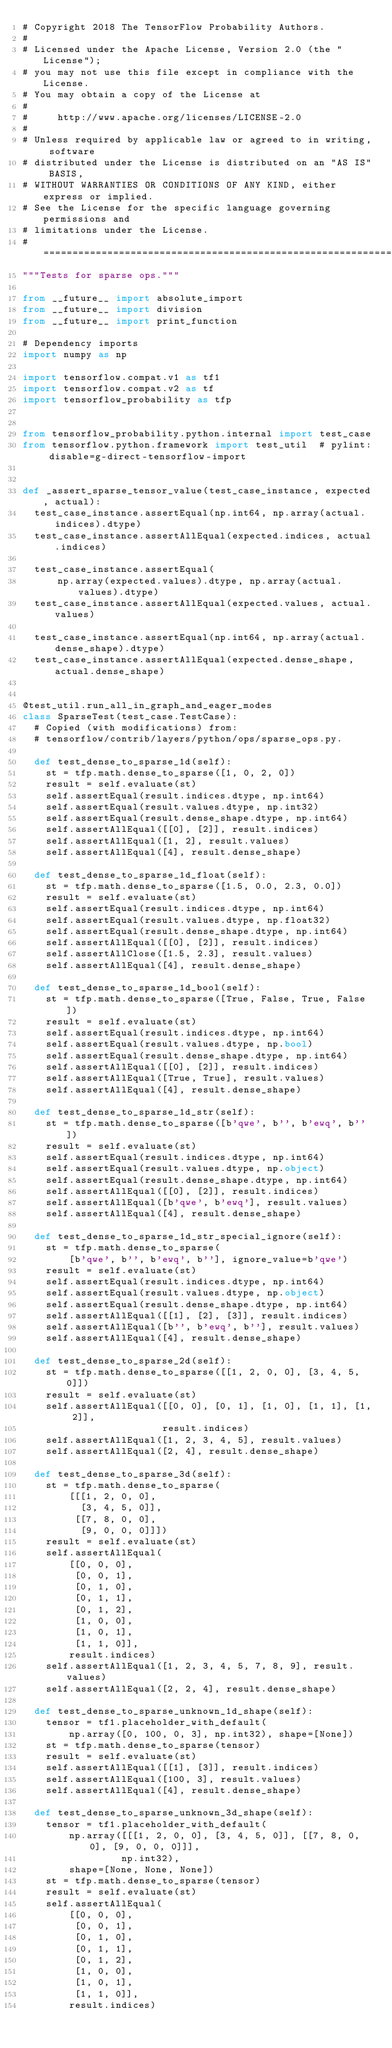<code> <loc_0><loc_0><loc_500><loc_500><_Python_># Copyright 2018 The TensorFlow Probability Authors.
#
# Licensed under the Apache License, Version 2.0 (the "License");
# you may not use this file except in compliance with the License.
# You may obtain a copy of the License at
#
#     http://www.apache.org/licenses/LICENSE-2.0
#
# Unless required by applicable law or agreed to in writing, software
# distributed under the License is distributed on an "AS IS" BASIS,
# WITHOUT WARRANTIES OR CONDITIONS OF ANY KIND, either express or implied.
# See the License for the specific language governing permissions and
# limitations under the License.
# ============================================================================
"""Tests for sparse ops."""

from __future__ import absolute_import
from __future__ import division
from __future__ import print_function

# Dependency imports
import numpy as np

import tensorflow.compat.v1 as tf1
import tensorflow.compat.v2 as tf
import tensorflow_probability as tfp


from tensorflow_probability.python.internal import test_case
from tensorflow.python.framework import test_util  # pylint: disable=g-direct-tensorflow-import


def _assert_sparse_tensor_value(test_case_instance, expected, actual):
  test_case_instance.assertEqual(np.int64, np.array(actual.indices).dtype)
  test_case_instance.assertAllEqual(expected.indices, actual.indices)

  test_case_instance.assertEqual(
      np.array(expected.values).dtype, np.array(actual.values).dtype)
  test_case_instance.assertAllEqual(expected.values, actual.values)

  test_case_instance.assertEqual(np.int64, np.array(actual.dense_shape).dtype)
  test_case_instance.assertAllEqual(expected.dense_shape, actual.dense_shape)


@test_util.run_all_in_graph_and_eager_modes
class SparseTest(test_case.TestCase):
  # Copied (with modifications) from:
  # tensorflow/contrib/layers/python/ops/sparse_ops.py.

  def test_dense_to_sparse_1d(self):
    st = tfp.math.dense_to_sparse([1, 0, 2, 0])
    result = self.evaluate(st)
    self.assertEqual(result.indices.dtype, np.int64)
    self.assertEqual(result.values.dtype, np.int32)
    self.assertEqual(result.dense_shape.dtype, np.int64)
    self.assertAllEqual([[0], [2]], result.indices)
    self.assertAllEqual([1, 2], result.values)
    self.assertAllEqual([4], result.dense_shape)

  def test_dense_to_sparse_1d_float(self):
    st = tfp.math.dense_to_sparse([1.5, 0.0, 2.3, 0.0])
    result = self.evaluate(st)
    self.assertEqual(result.indices.dtype, np.int64)
    self.assertEqual(result.values.dtype, np.float32)
    self.assertEqual(result.dense_shape.dtype, np.int64)
    self.assertAllEqual([[0], [2]], result.indices)
    self.assertAllClose([1.5, 2.3], result.values)
    self.assertAllEqual([4], result.dense_shape)

  def test_dense_to_sparse_1d_bool(self):
    st = tfp.math.dense_to_sparse([True, False, True, False])
    result = self.evaluate(st)
    self.assertEqual(result.indices.dtype, np.int64)
    self.assertEqual(result.values.dtype, np.bool)
    self.assertEqual(result.dense_shape.dtype, np.int64)
    self.assertAllEqual([[0], [2]], result.indices)
    self.assertAllEqual([True, True], result.values)
    self.assertAllEqual([4], result.dense_shape)

  def test_dense_to_sparse_1d_str(self):
    st = tfp.math.dense_to_sparse([b'qwe', b'', b'ewq', b''])
    result = self.evaluate(st)
    self.assertEqual(result.indices.dtype, np.int64)
    self.assertEqual(result.values.dtype, np.object)
    self.assertEqual(result.dense_shape.dtype, np.int64)
    self.assertAllEqual([[0], [2]], result.indices)
    self.assertAllEqual([b'qwe', b'ewq'], result.values)
    self.assertAllEqual([4], result.dense_shape)

  def test_dense_to_sparse_1d_str_special_ignore(self):
    st = tfp.math.dense_to_sparse(
        [b'qwe', b'', b'ewq', b''], ignore_value=b'qwe')
    result = self.evaluate(st)
    self.assertEqual(result.indices.dtype, np.int64)
    self.assertEqual(result.values.dtype, np.object)
    self.assertEqual(result.dense_shape.dtype, np.int64)
    self.assertAllEqual([[1], [2], [3]], result.indices)
    self.assertAllEqual([b'', b'ewq', b''], result.values)
    self.assertAllEqual([4], result.dense_shape)

  def test_dense_to_sparse_2d(self):
    st = tfp.math.dense_to_sparse([[1, 2, 0, 0], [3, 4, 5, 0]])
    result = self.evaluate(st)
    self.assertAllEqual([[0, 0], [0, 1], [1, 0], [1, 1], [1, 2]],
                        result.indices)
    self.assertAllEqual([1, 2, 3, 4, 5], result.values)
    self.assertAllEqual([2, 4], result.dense_shape)

  def test_dense_to_sparse_3d(self):
    st = tfp.math.dense_to_sparse(
        [[[1, 2, 0, 0],
          [3, 4, 5, 0]],
         [[7, 8, 0, 0],
          [9, 0, 0, 0]]])
    result = self.evaluate(st)
    self.assertAllEqual(
        [[0, 0, 0],
         [0, 0, 1],
         [0, 1, 0],
         [0, 1, 1],
         [0, 1, 2],
         [1, 0, 0],
         [1, 0, 1],
         [1, 1, 0]],
        result.indices)
    self.assertAllEqual([1, 2, 3, 4, 5, 7, 8, 9], result.values)
    self.assertAllEqual([2, 2, 4], result.dense_shape)

  def test_dense_to_sparse_unknown_1d_shape(self):
    tensor = tf1.placeholder_with_default(
        np.array([0, 100, 0, 3], np.int32), shape=[None])
    st = tfp.math.dense_to_sparse(tensor)
    result = self.evaluate(st)
    self.assertAllEqual([[1], [3]], result.indices)
    self.assertAllEqual([100, 3], result.values)
    self.assertAllEqual([4], result.dense_shape)

  def test_dense_to_sparse_unknown_3d_shape(self):
    tensor = tf1.placeholder_with_default(
        np.array([[[1, 2, 0, 0], [3, 4, 5, 0]], [[7, 8, 0, 0], [9, 0, 0, 0]]],
                 np.int32),
        shape=[None, None, None])
    st = tfp.math.dense_to_sparse(tensor)
    result = self.evaluate(st)
    self.assertAllEqual(
        [[0, 0, 0],
         [0, 0, 1],
         [0, 1, 0],
         [0, 1, 1],
         [0, 1, 2],
         [1, 0, 0],
         [1, 0, 1],
         [1, 1, 0]],
        result.indices)</code> 